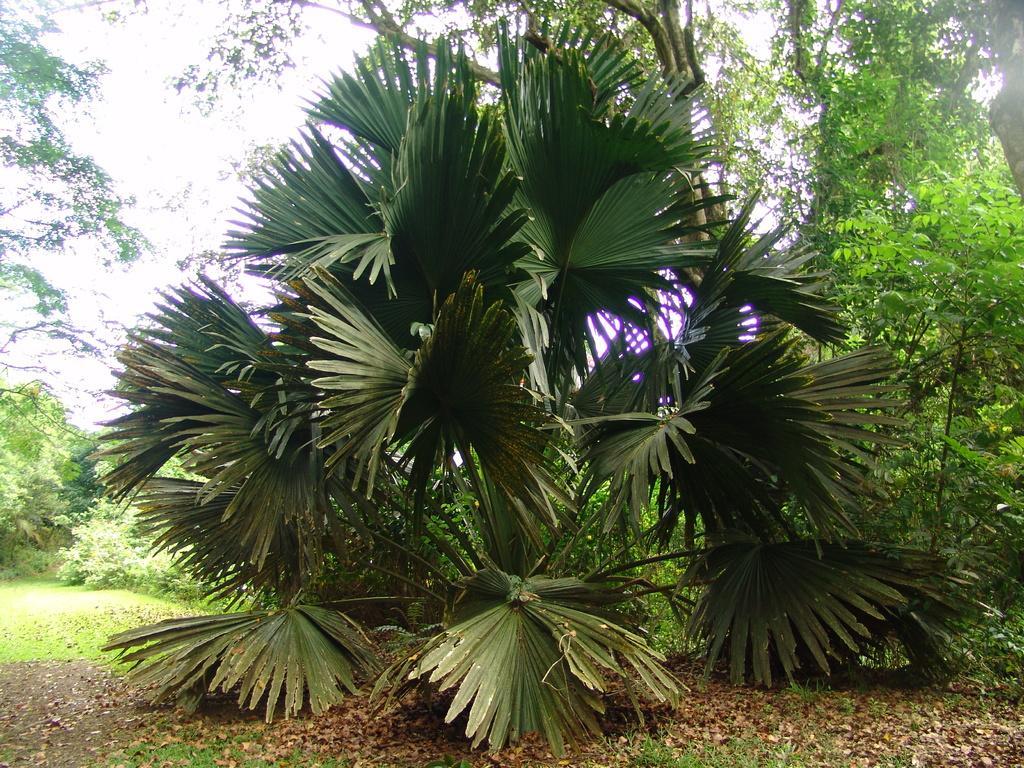In one or two sentences, can you explain what this image depicts? In this image there are trees and there's grass on the surface. At the background there is sky. 